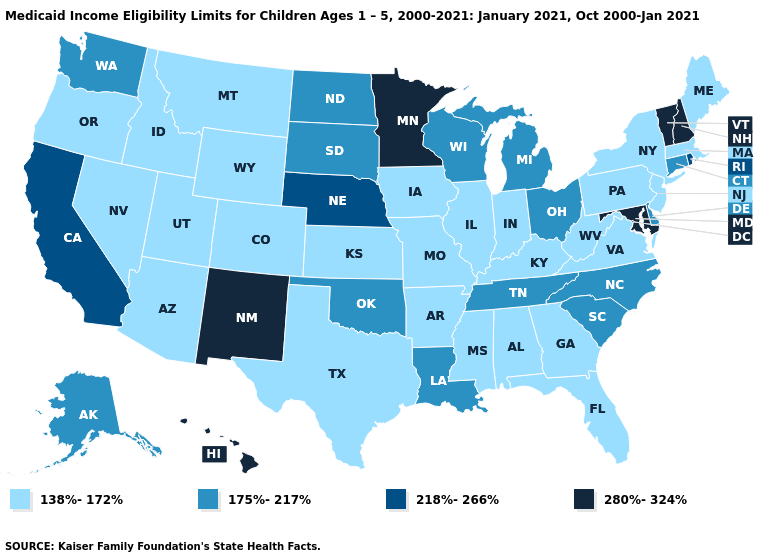What is the highest value in the MidWest ?
Keep it brief. 280%-324%. Does Mississippi have the highest value in the USA?
Answer briefly. No. What is the value of Colorado?
Quick response, please. 138%-172%. What is the highest value in states that border Virginia?
Concise answer only. 280%-324%. What is the highest value in states that border Utah?
Quick response, please. 280%-324%. Does Maine have the lowest value in the USA?
Quick response, please. Yes. Among the states that border Wyoming , which have the lowest value?
Be succinct. Colorado, Idaho, Montana, Utah. Among the states that border Connecticut , which have the lowest value?
Short answer required. Massachusetts, New York. Does Hawaii have the lowest value in the West?
Concise answer only. No. What is the value of Oregon?
Answer briefly. 138%-172%. Is the legend a continuous bar?
Be succinct. No. What is the value of Virginia?
Quick response, please. 138%-172%. Among the states that border Kansas , does Nebraska have the lowest value?
Write a very short answer. No. Name the states that have a value in the range 280%-324%?
Write a very short answer. Hawaii, Maryland, Minnesota, New Hampshire, New Mexico, Vermont. What is the value of Oklahoma?
Be succinct. 175%-217%. 